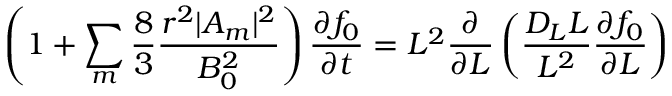<formula> <loc_0><loc_0><loc_500><loc_500>\left ( 1 + \sum _ { m } \frac { 8 } { 3 } \frac { r ^ { 2 } | A _ { m } | ^ { 2 } } { B _ { 0 } ^ { 2 } } \right ) \frac { \partial f _ { 0 } } { \partial t } = L ^ { 2 } \frac { \partial } { \partial L } \left ( \frac { D _ { L } L } { L ^ { 2 } } \frac { \partial f _ { 0 } } { \partial L } \right )</formula> 